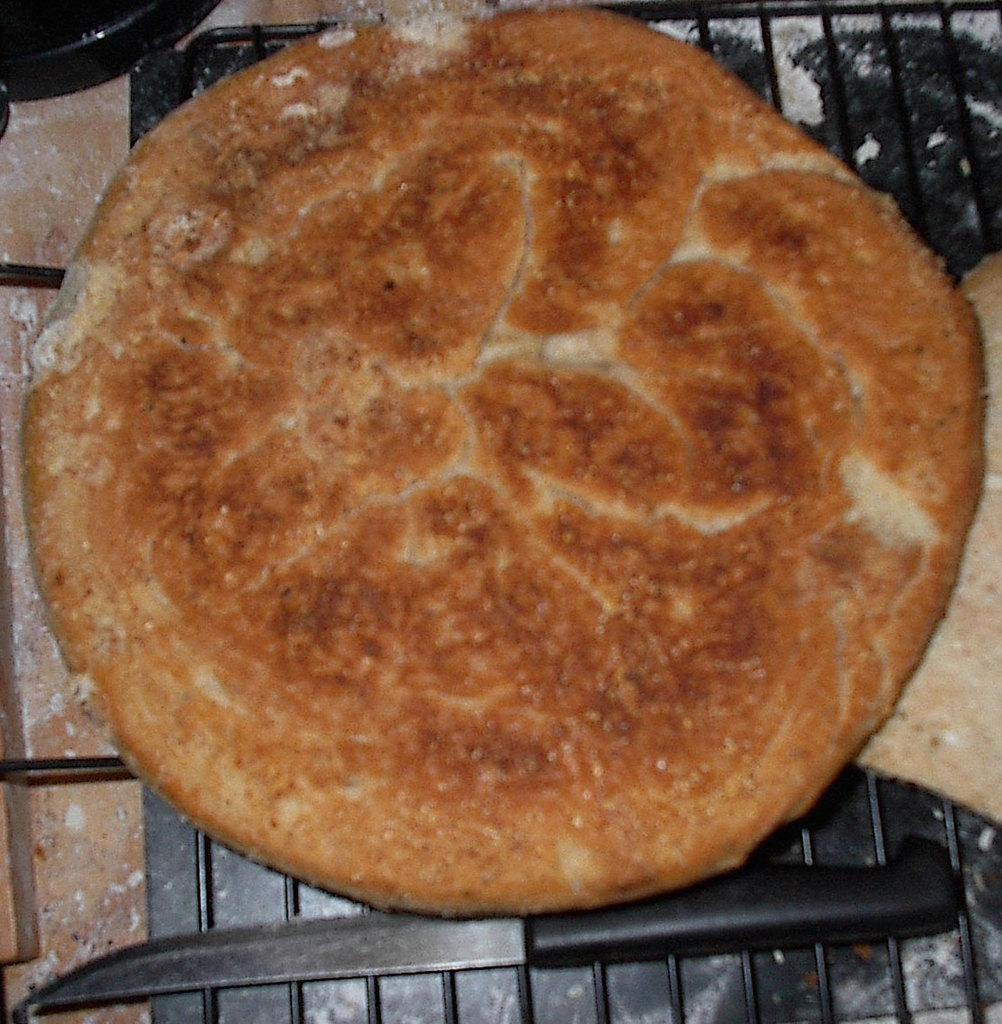Can you describe this image briefly? As we can see in the image there is knife and dish. 